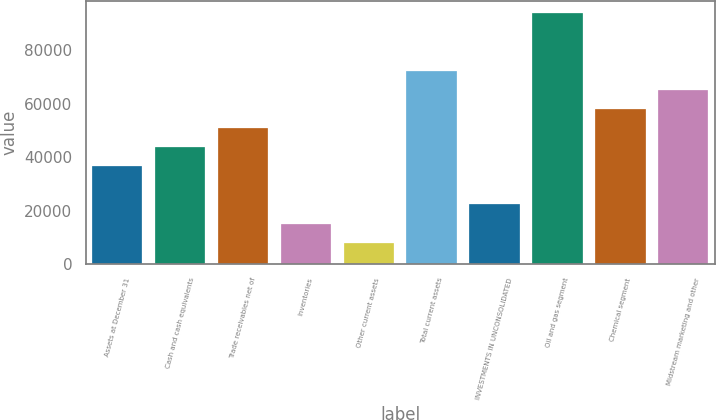Convert chart. <chart><loc_0><loc_0><loc_500><loc_500><bar_chart><fcel>Assets at December 31<fcel>Cash and cash equivalents<fcel>Trade receivables net of<fcel>Inventories<fcel>Other current assets<fcel>Total current assets<fcel>INVESTMENTS IN UNCONSOLIDATED<fcel>Oil and gas segment<fcel>Chemical segment<fcel>Midstream marketing and other<nl><fcel>36603.5<fcel>43756.2<fcel>50908.9<fcel>15145.4<fcel>7992.7<fcel>72367<fcel>22298.1<fcel>93825.1<fcel>58061.6<fcel>65214.3<nl></chart> 